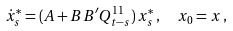Convert formula to latex. <formula><loc_0><loc_0><loc_500><loc_500>\dot { x } _ { s } ^ { * } & = ( A + B B ^ { \prime } Q _ { t - s } ^ { 1 1 } ) \, x _ { s } ^ { * } \, , \quad x _ { 0 } = x \, ,</formula> 